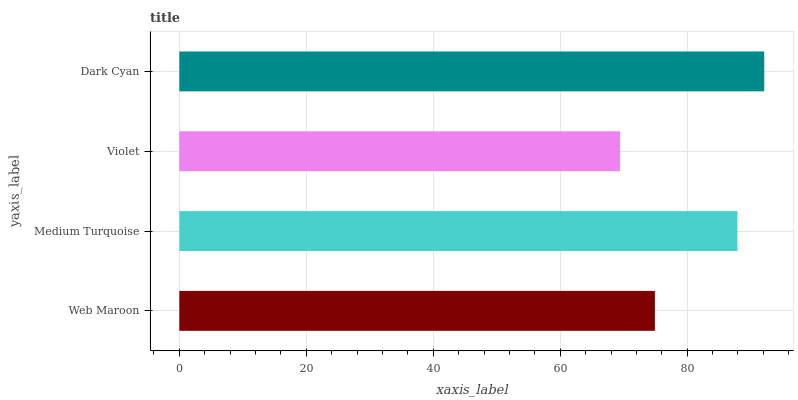Is Violet the minimum?
Answer yes or no. Yes. Is Dark Cyan the maximum?
Answer yes or no. Yes. Is Medium Turquoise the minimum?
Answer yes or no. No. Is Medium Turquoise the maximum?
Answer yes or no. No. Is Medium Turquoise greater than Web Maroon?
Answer yes or no. Yes. Is Web Maroon less than Medium Turquoise?
Answer yes or no. Yes. Is Web Maroon greater than Medium Turquoise?
Answer yes or no. No. Is Medium Turquoise less than Web Maroon?
Answer yes or no. No. Is Medium Turquoise the high median?
Answer yes or no. Yes. Is Web Maroon the low median?
Answer yes or no. Yes. Is Violet the high median?
Answer yes or no. No. Is Dark Cyan the low median?
Answer yes or no. No. 